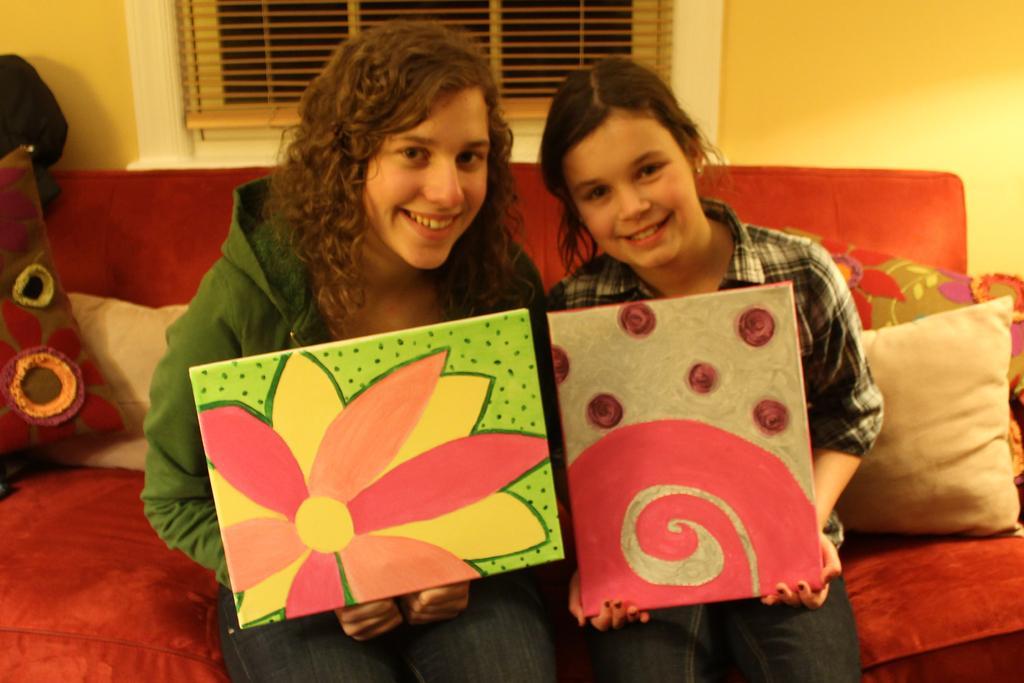Can you describe this image briefly? In this picture we can see girls sitting on the couch. Here we can see pillows. They are holding painting boards in their hands and smiling. In the background we can see a wall painted with yellow paint and this is a window blind. 